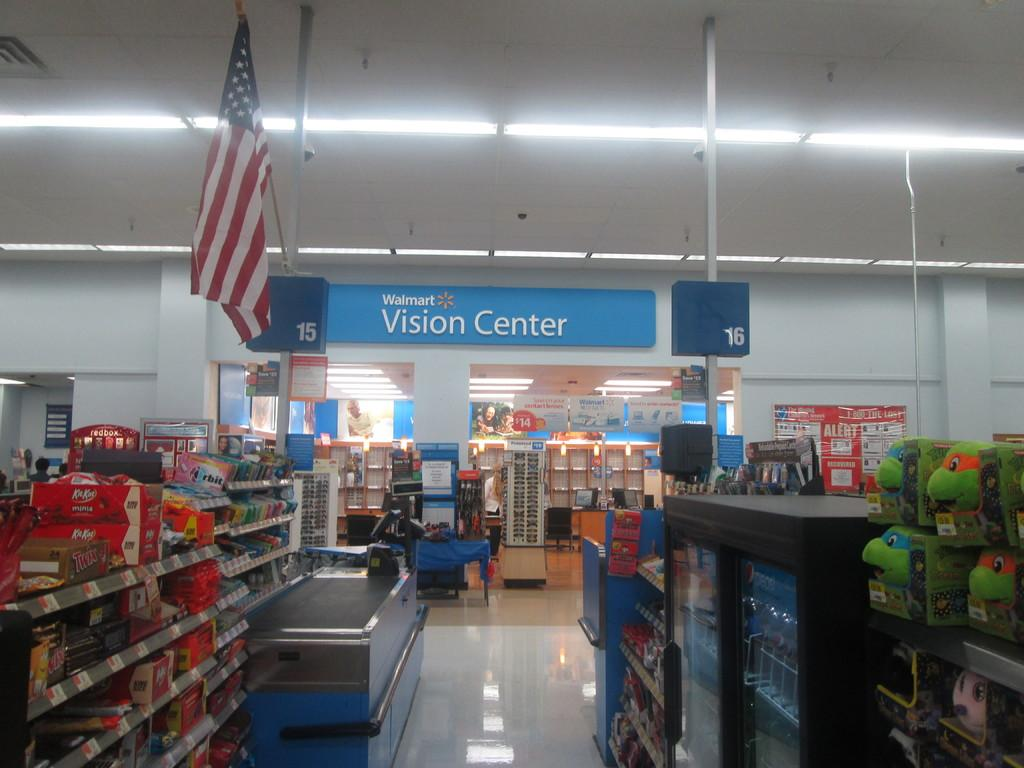<image>
Relay a brief, clear account of the picture shown. Walmart shopping center that includes a vision center 